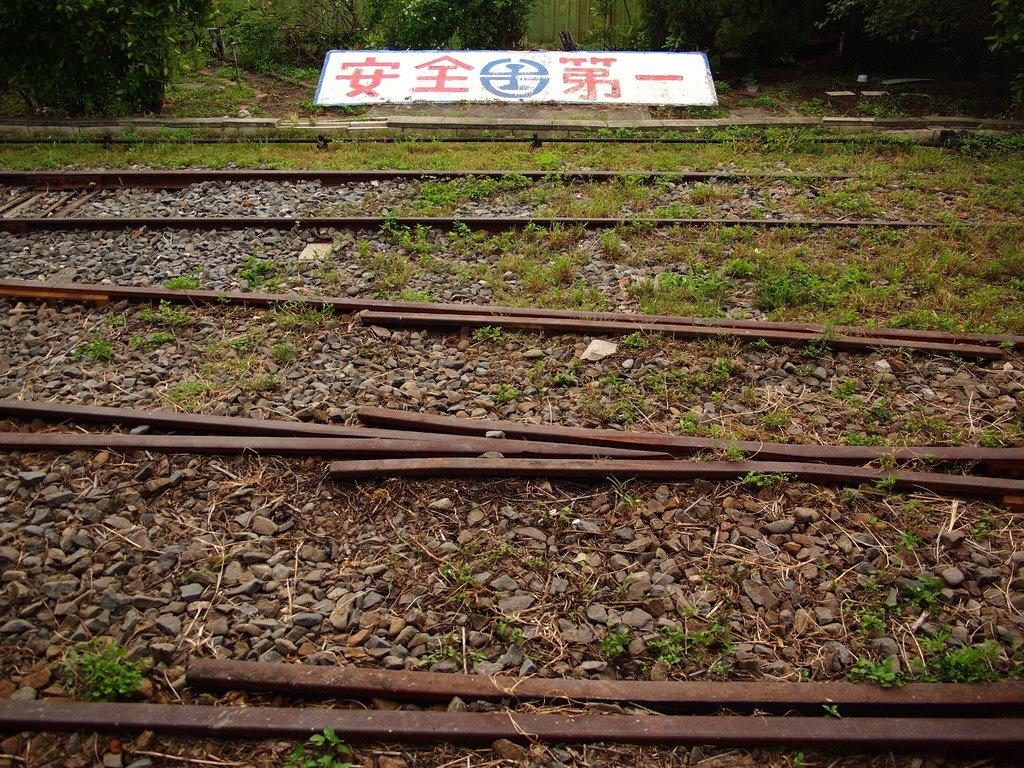What type of natural elements can be seen in the image? There are stones and grass visible in the image. What man-made structures are present in the image? Railway tracks are present in the image. What can be seen in the background of the image? There are plants and a board in the background of the image. What songs are being sung by the person in the image? There is no person present in the image, so no songs can be heard or sung. What type of card is visible in the image? There is no card present in the image. 